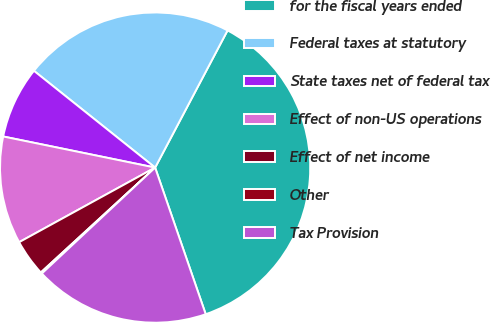Convert chart. <chart><loc_0><loc_0><loc_500><loc_500><pie_chart><fcel>for the fiscal years ended<fcel>Federal taxes at statutory<fcel>State taxes net of federal tax<fcel>Effect of non-US operations<fcel>Effect of net income<fcel>Other<fcel>Tax Provision<nl><fcel>36.98%<fcel>22.01%<fcel>7.51%<fcel>11.2%<fcel>3.83%<fcel>0.15%<fcel>18.32%<nl></chart> 